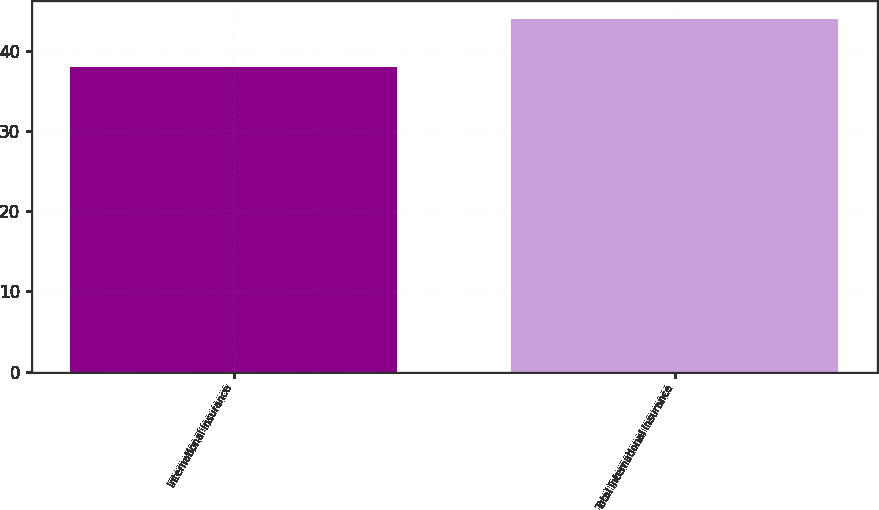<chart> <loc_0><loc_0><loc_500><loc_500><bar_chart><fcel>International Insurance<fcel>Total International Insurance<nl><fcel>38<fcel>44<nl></chart> 